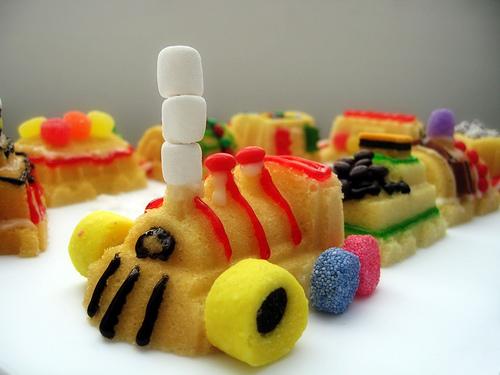How many marshmallows are here?
Answer briefly. 3. What does this resemble?
Write a very short answer. Train. What kind of food represents the smokestack?
Give a very brief answer. Marshmallows. What is the food shaped like?
Concise answer only. Train. 